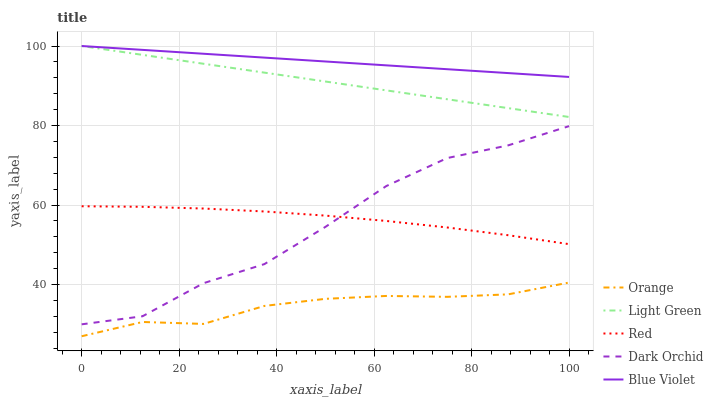Does Dark Orchid have the minimum area under the curve?
Answer yes or no. No. Does Dark Orchid have the maximum area under the curve?
Answer yes or no. No. Is Dark Orchid the smoothest?
Answer yes or no. No. Is Blue Violet the roughest?
Answer yes or no. No. Does Dark Orchid have the lowest value?
Answer yes or no. No. Does Dark Orchid have the highest value?
Answer yes or no. No. Is Red less than Blue Violet?
Answer yes or no. Yes. Is Blue Violet greater than Red?
Answer yes or no. Yes. Does Red intersect Blue Violet?
Answer yes or no. No. 